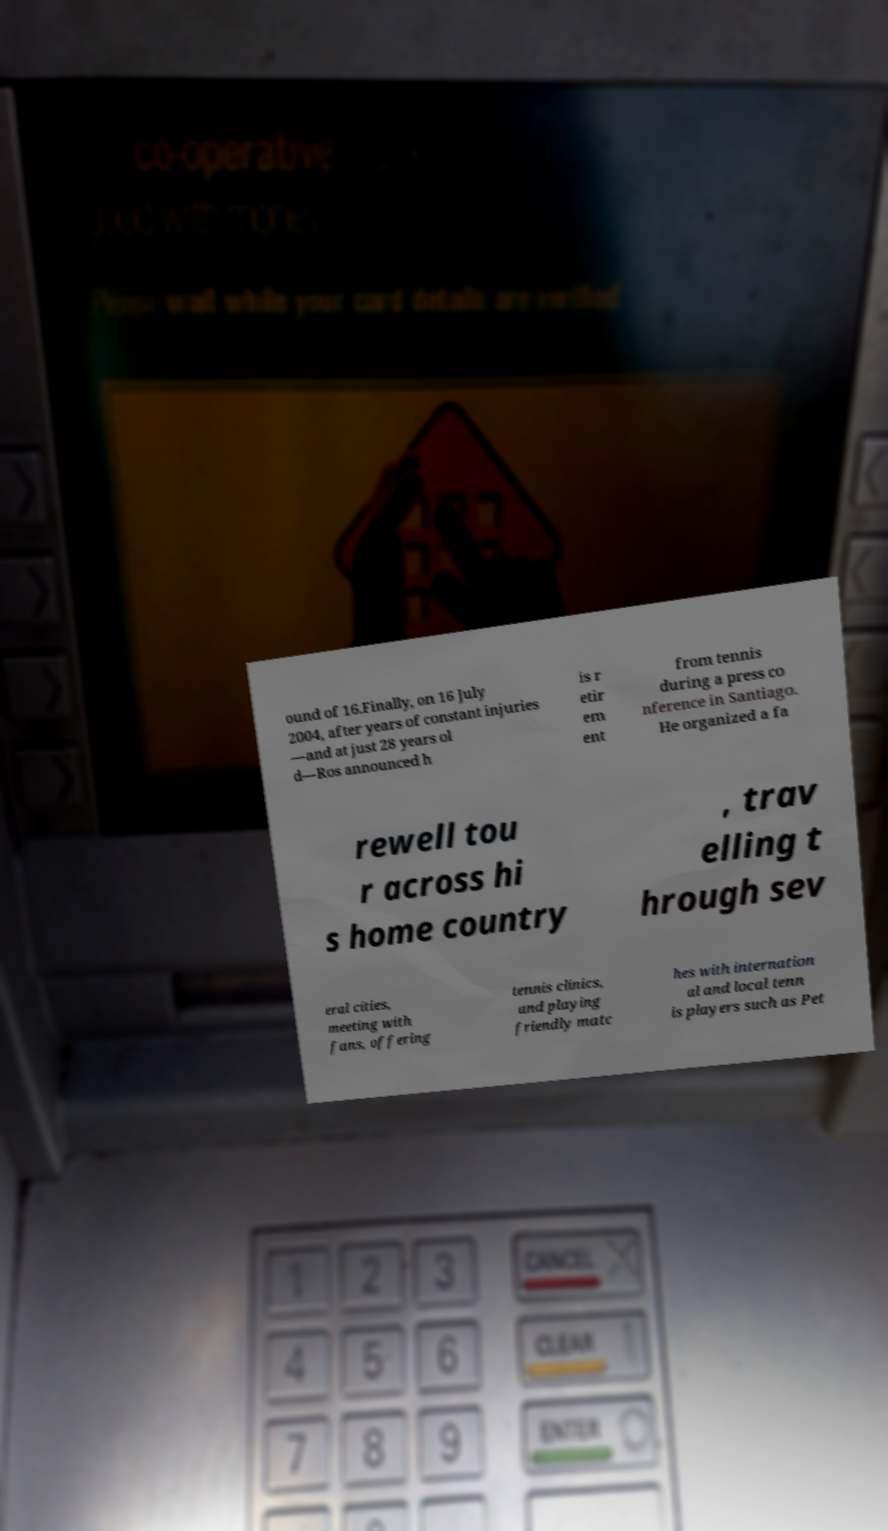Could you extract and type out the text from this image? ound of 16.Finally, on 16 July 2004, after years of constant injuries —and at just 28 years ol d—Ros announced h is r etir em ent from tennis during a press co nference in Santiago. He organized a fa rewell tou r across hi s home country , trav elling t hrough sev eral cities, meeting with fans, offering tennis clinics, and playing friendly matc hes with internation al and local tenn is players such as Pet 